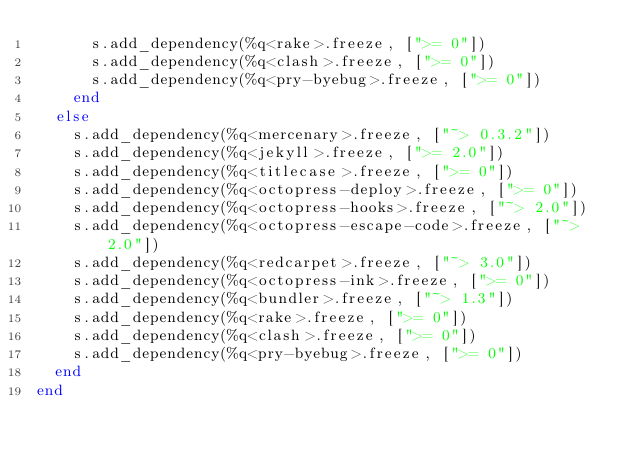Convert code to text. <code><loc_0><loc_0><loc_500><loc_500><_Ruby_>      s.add_dependency(%q<rake>.freeze, [">= 0"])
      s.add_dependency(%q<clash>.freeze, [">= 0"])
      s.add_dependency(%q<pry-byebug>.freeze, [">= 0"])
    end
  else
    s.add_dependency(%q<mercenary>.freeze, ["~> 0.3.2"])
    s.add_dependency(%q<jekyll>.freeze, [">= 2.0"])
    s.add_dependency(%q<titlecase>.freeze, [">= 0"])
    s.add_dependency(%q<octopress-deploy>.freeze, [">= 0"])
    s.add_dependency(%q<octopress-hooks>.freeze, ["~> 2.0"])
    s.add_dependency(%q<octopress-escape-code>.freeze, ["~> 2.0"])
    s.add_dependency(%q<redcarpet>.freeze, ["~> 3.0"])
    s.add_dependency(%q<octopress-ink>.freeze, [">= 0"])
    s.add_dependency(%q<bundler>.freeze, ["~> 1.3"])
    s.add_dependency(%q<rake>.freeze, [">= 0"])
    s.add_dependency(%q<clash>.freeze, [">= 0"])
    s.add_dependency(%q<pry-byebug>.freeze, [">= 0"])
  end
end
</code> 